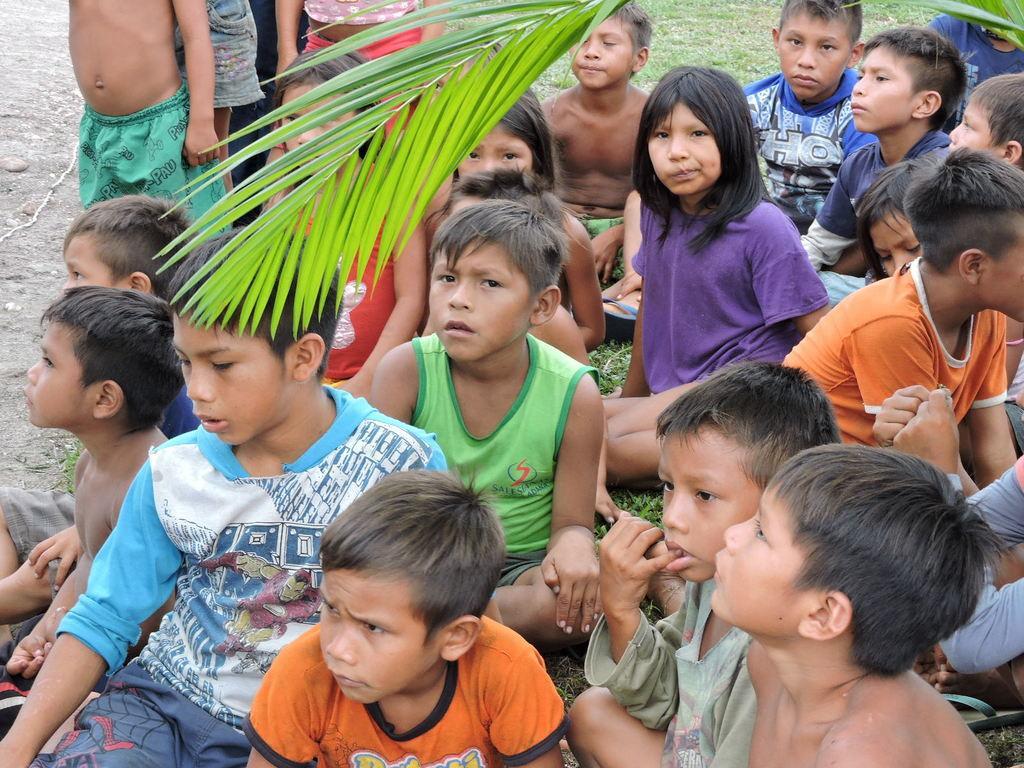Describe this image in one or two sentences. In this image there are group of kids sitting on the ground. At the top there are green leaves. 